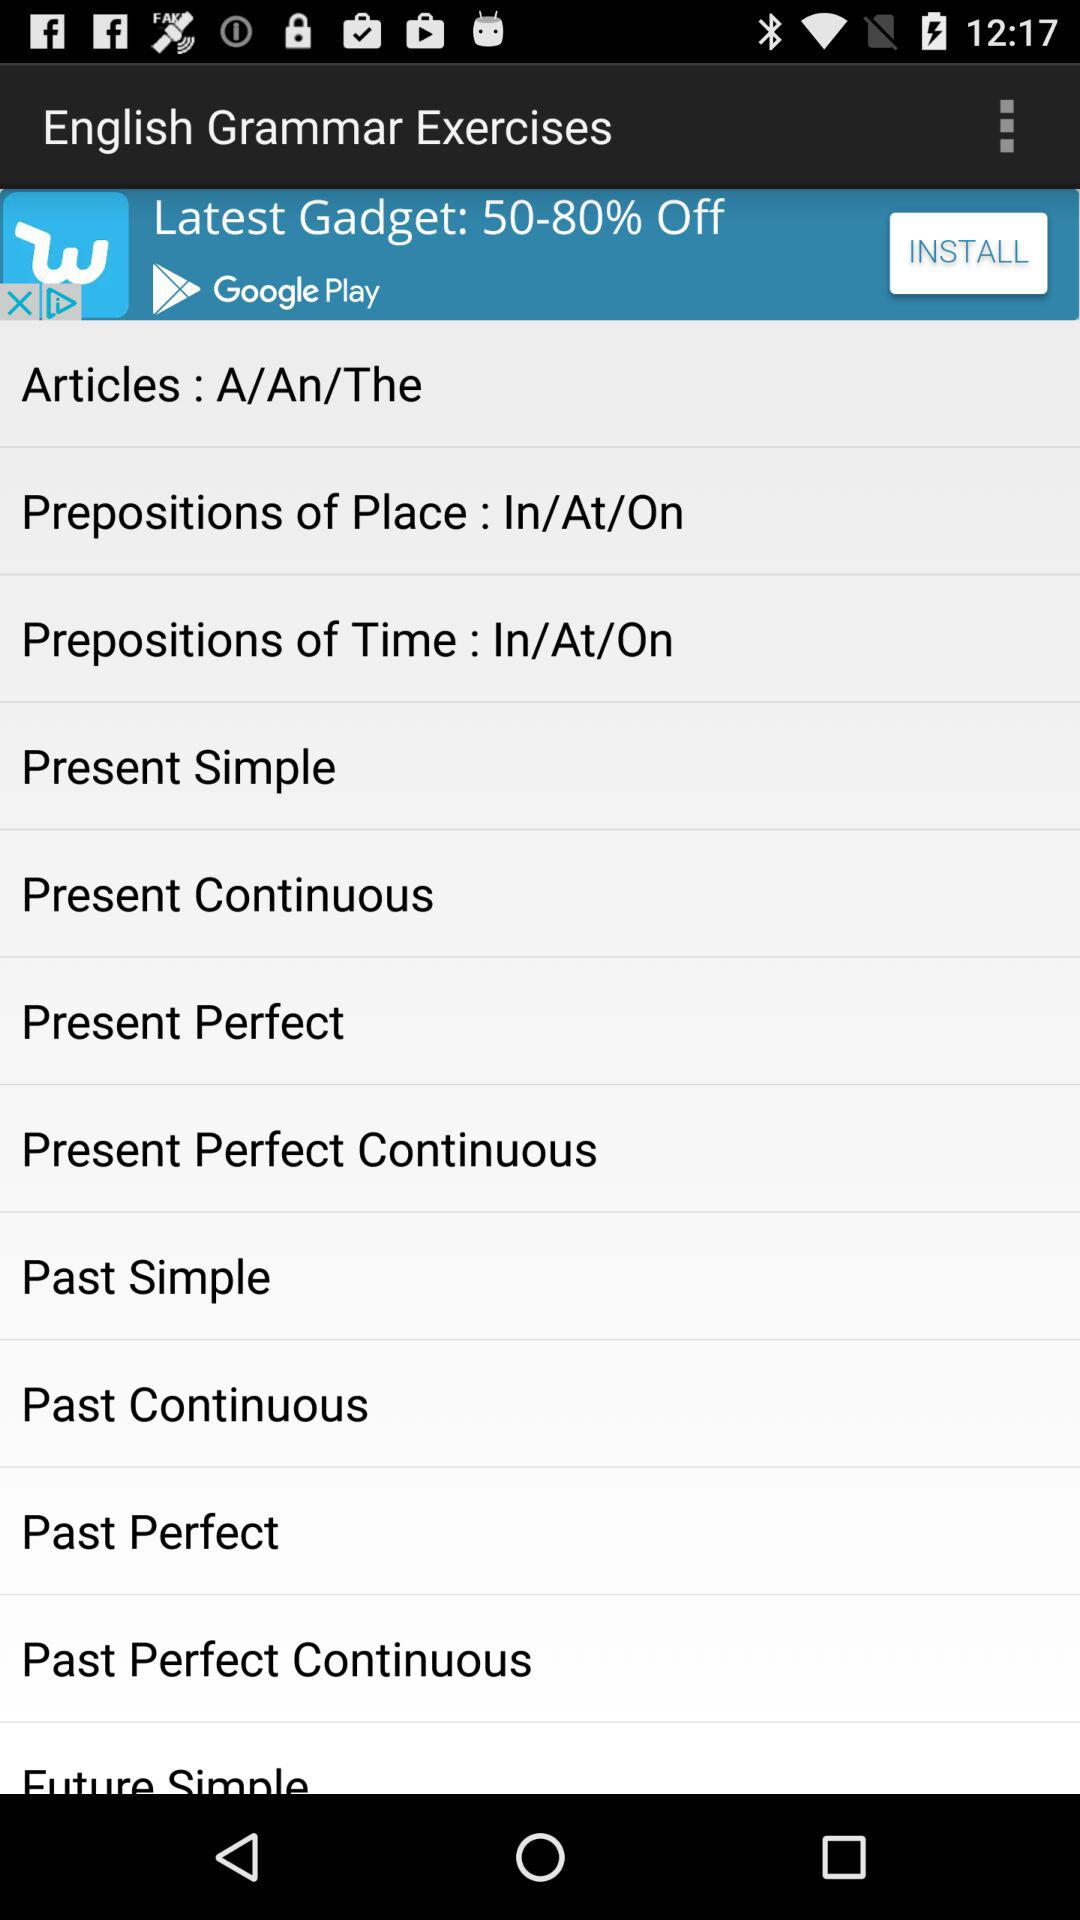What is the application name? The application name is "English Grammar Exercises". 